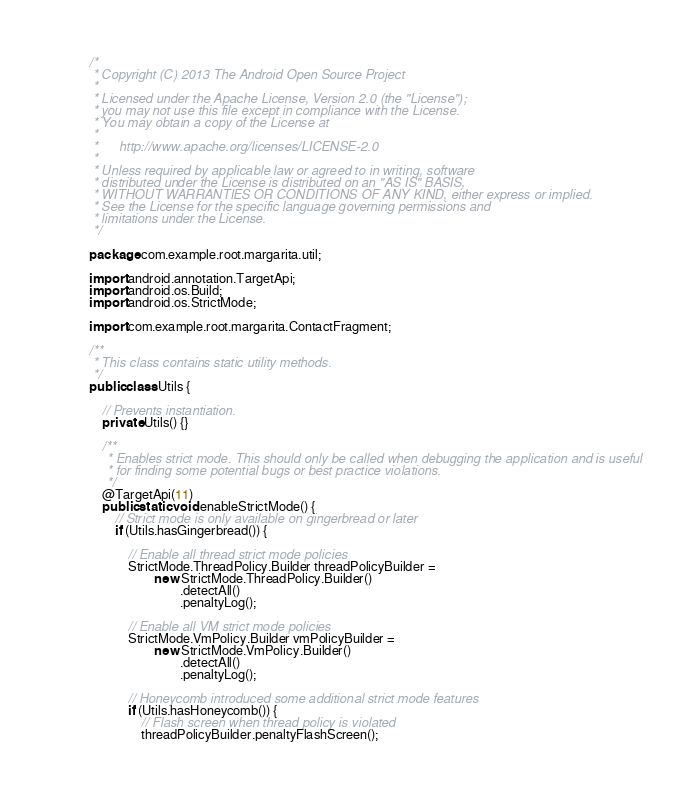<code> <loc_0><loc_0><loc_500><loc_500><_Java_>/*
 * Copyright (C) 2013 The Android Open Source Project
 *
 * Licensed under the Apache License, Version 2.0 (the "License");
 * you may not use this file except in compliance with the License.
 * You may obtain a copy of the License at
 *
 *      http://www.apache.org/licenses/LICENSE-2.0
 *
 * Unless required by applicable law or agreed to in writing, software
 * distributed under the License is distributed on an "AS IS" BASIS,
 * WITHOUT WARRANTIES OR CONDITIONS OF ANY KIND, either express or implied.
 * See the License for the specific language governing permissions and
 * limitations under the License.
 */

package com.example.root.margarita.util;

import android.annotation.TargetApi;
import android.os.Build;
import android.os.StrictMode;

import com.example.root.margarita.ContactFragment;

/**
 * This class contains static utility methods.
 */
public class Utils {

    // Prevents instantiation.
    private Utils() {}

    /**
     * Enables strict mode. This should only be called when debugging the application and is useful
     * for finding some potential bugs or best practice violations.
     */
    @TargetApi(11)
    public static void enableStrictMode() {
        // Strict mode is only available on gingerbread or later
        if (Utils.hasGingerbread()) {

            // Enable all thread strict mode policies
            StrictMode.ThreadPolicy.Builder threadPolicyBuilder =
                    new StrictMode.ThreadPolicy.Builder()
                            .detectAll()
                            .penaltyLog();

            // Enable all VM strict mode policies
            StrictMode.VmPolicy.Builder vmPolicyBuilder =
                    new StrictMode.VmPolicy.Builder()
                            .detectAll()
                            .penaltyLog();

            // Honeycomb introduced some additional strict mode features
            if (Utils.hasHoneycomb()) {
                // Flash screen when thread policy is violated
                threadPolicyBuilder.penaltyFlashScreen();</code> 